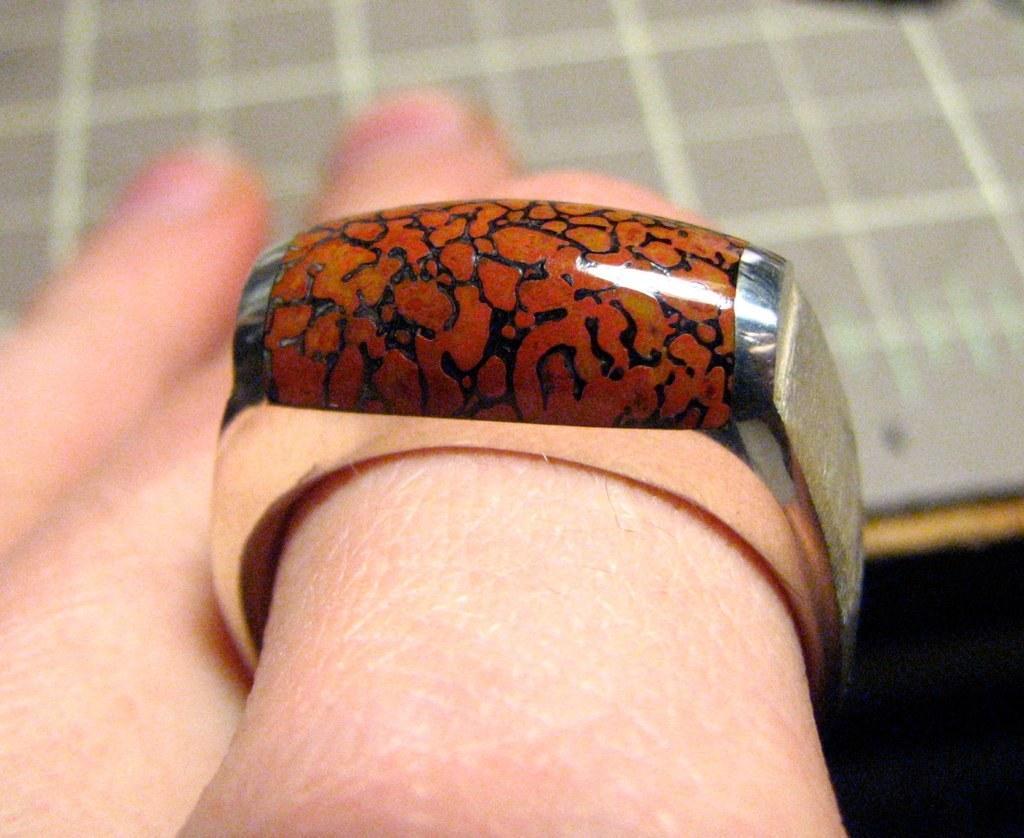Describe this image in one or two sentences. In this image I can see a person's hand and there is a ring to a finger. In the background there is an object. 